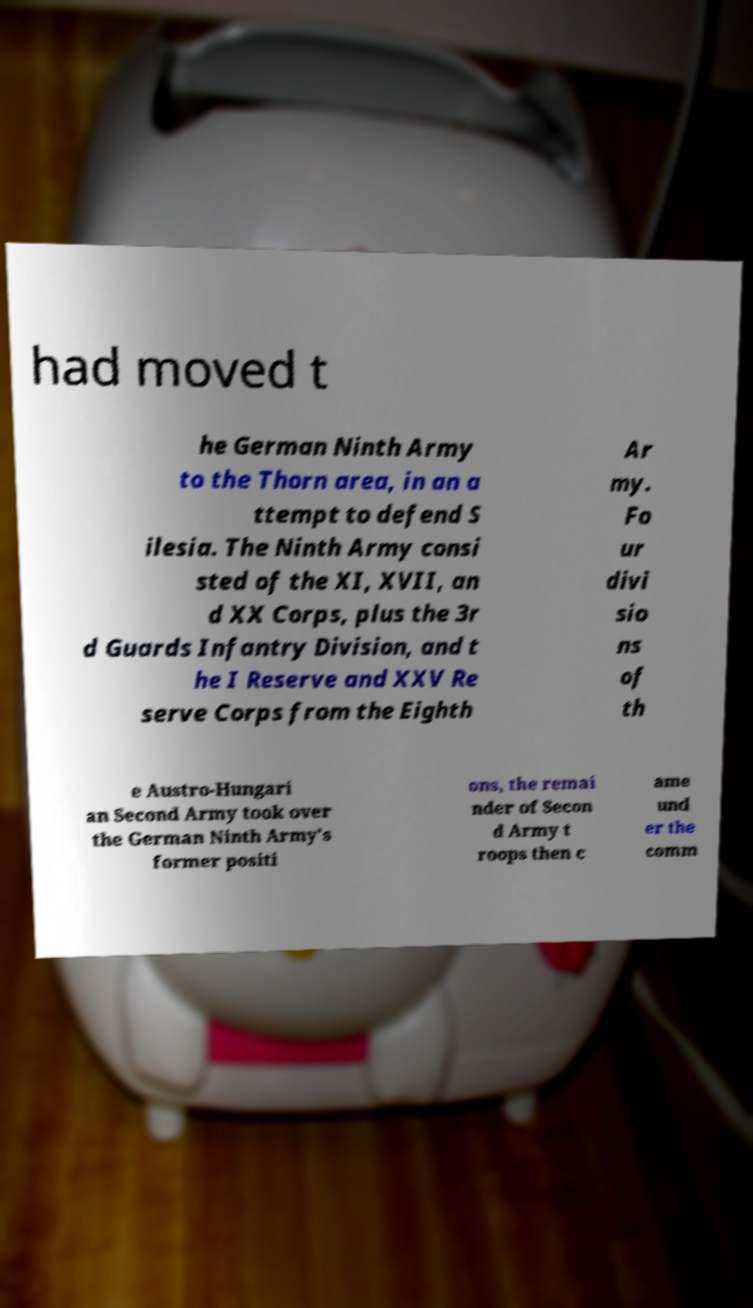Can you read and provide the text displayed in the image?This photo seems to have some interesting text. Can you extract and type it out for me? had moved t he German Ninth Army to the Thorn area, in an a ttempt to defend S ilesia. The Ninth Army consi sted of the XI, XVII, an d XX Corps, plus the 3r d Guards Infantry Division, and t he I Reserve and XXV Re serve Corps from the Eighth Ar my. Fo ur divi sio ns of th e Austro-Hungari an Second Army took over the German Ninth Army's former positi ons, the remai nder of Secon d Army t roops then c ame und er the comm 